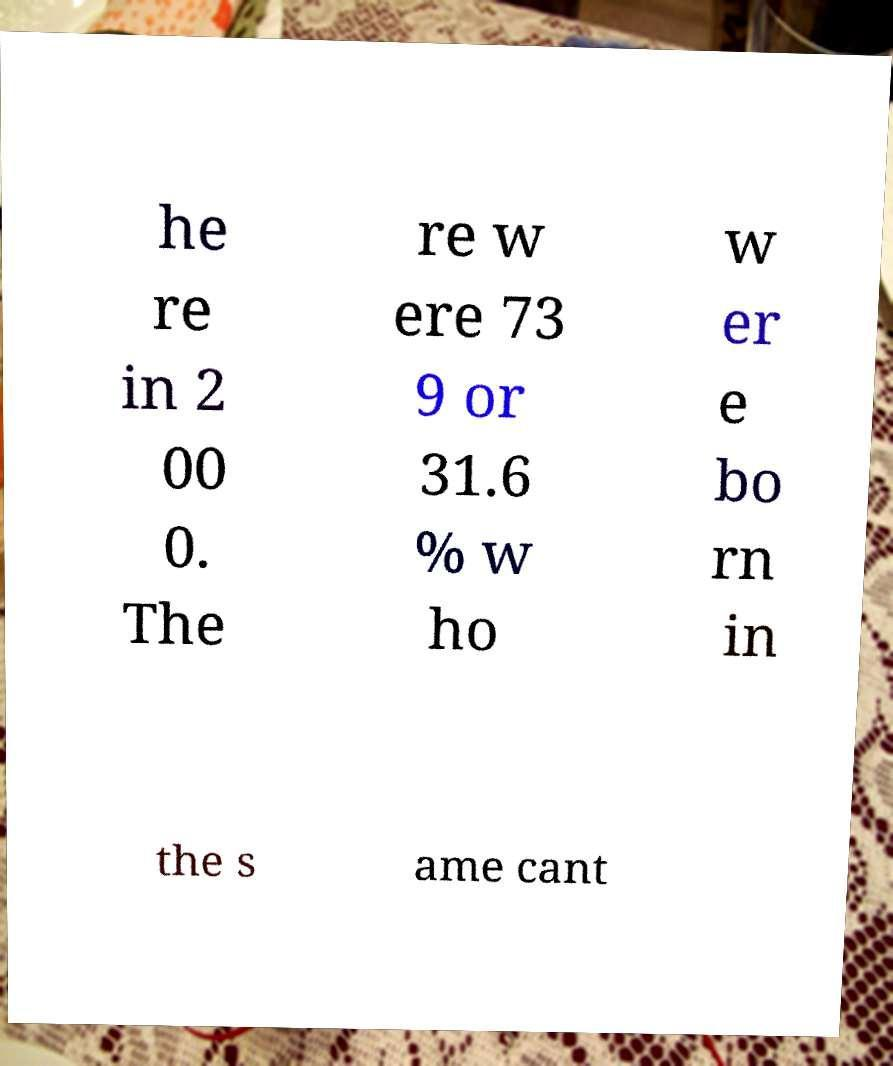Can you accurately transcribe the text from the provided image for me? he re in 2 00 0. The re w ere 73 9 or 31.6 % w ho w er e bo rn in the s ame cant 